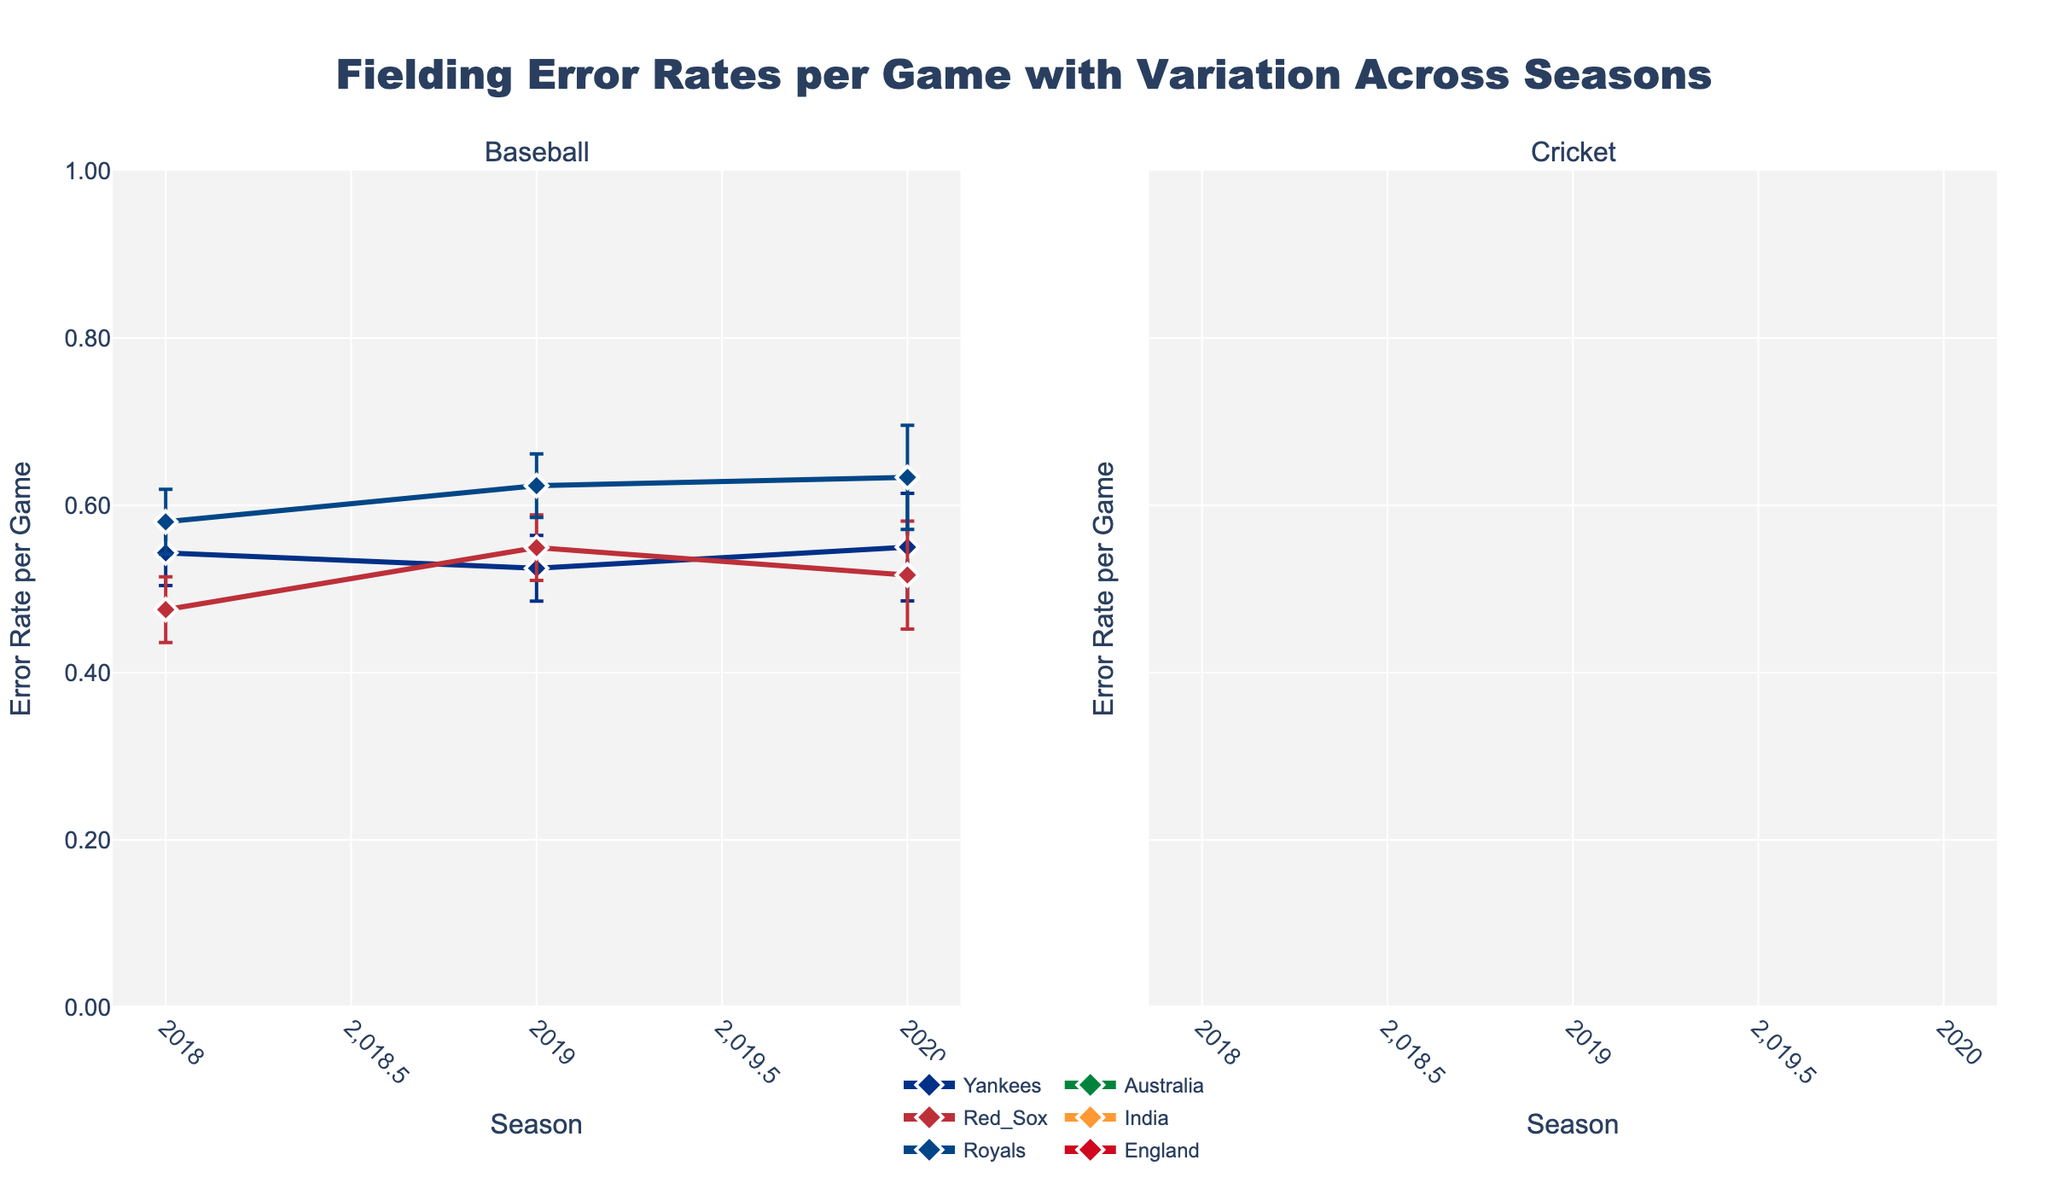What is the title of this figure? The title of the figure is displayed prominently at the top. It reads "Fielding Error Rates per Game with Variation Across Seasons".
Answer: Fielding Error Rates per Game with Variation Across Seasons Which sport shows a wider range of error rates among its teams across the seasons? Looking at both subplots, the error rates in baseball teams vary more widely compared to cricket teams. Baseball's error rates range from around 0.1 to over 0.5, while cricket's error rates are more tightly clustered around 0.1 to 0.2.
Answer: Baseball What are the error rates for the Yankees in 2019 and how do they compare to the Royals in the same year? The error rates for the Yankees in 2019 can be found in the first subplot under "Baseball". The Yankees' rate is approximately 0.52, while the Royals' rate is approximately 0.62, indicating the Royals had a higher error rate.
Answer: Yankees: 0.52, Royals: 0.62 Which team in cricket has the lowest fielding error rate in 2020? Look at the second subplot under "Cricket" and find the error rates for 2020. The lowest error rate belongs to England, which is around 0.12.
Answer: England How does the fielding error rate of the Red Sox in 2018 compare to their rate in 2020? In the subplot for Baseball, locate the error rates for the Red Sox in 2018 and 2020. The error rate in 2018 is around 0.48 while in 2020 it is around 0.52, indicating an increase over this period.
Answer: 2018: 0.48, 2020: 0.52 Are the error bars wider for baseball or cricket teams, and what does this indicate? Comparing both subplots, error bars for baseball teams appear wider than those for cricket teams. Wider error bars indicate more variability in the data or less precision in the error rate estimates.
Answer: Baseball What trend can be observed for India in cricket over the three seasons? In the cricket subplot, trace the line for India. The error rate shows a decreasing trend from around 0.1 to 0.08 over the seasons 2018 to 2020.
Answer: Decreasing trend Which team has the largest error rate in any season among baseball teams? From the baseball subplot, visually inspect the data points. The Royals have the highest error rate, approximately 0.63, in 2019.
Answer: Royals in 2019 What is the average fielding error rate for England in cricket over the three seasons? Average out the error rates for England in 2018 (about 0.15), 2019 (about 0.13), and 2020 (about 0.12). Summing these rates, we get 0.15 + 0.13 + 0.12 = 0.40. Dividing by 3 gives approximately 0.133.
Answer: Around 0.133 